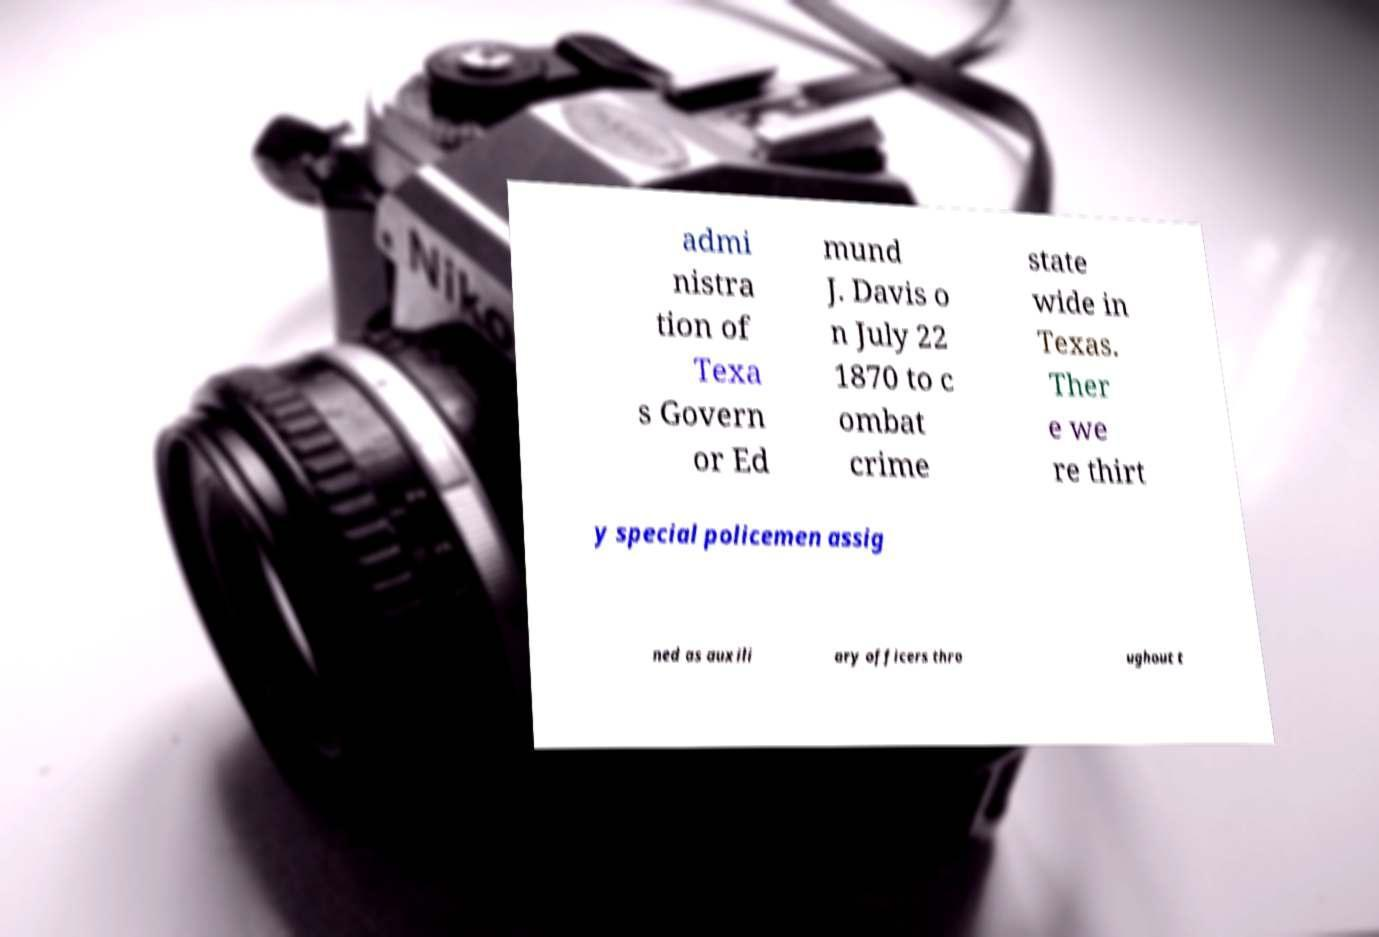Could you assist in decoding the text presented in this image and type it out clearly? admi nistra tion of Texa s Govern or Ed mund J. Davis o n July 22 1870 to c ombat crime state wide in Texas. Ther e we re thirt y special policemen assig ned as auxili ary officers thro ughout t 